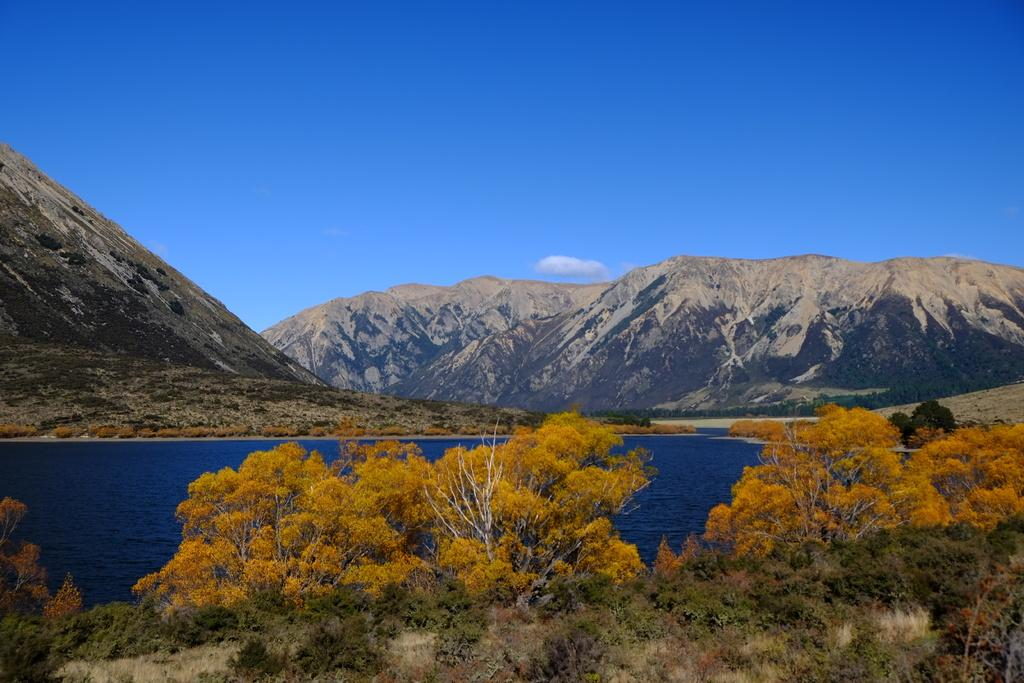What type of vegetation can be seen in the image? There are trees and plants visible in the image. What natural feature is present in the image? There are mountains in the image. What can be seen in the water in the image? The facts do not specify what can be seen in the water. What is visible in the background of the image? The sky is visible in the background of the image, and clouds are present in the sky. What type of roof can be seen on the trees in the image? There is no roof present on the trees in the image; trees do not have roofs. Can you describe the fight between the scissors and the clouds in the image? There is no fight between scissors and clouds in the image, as neither scissors nor a fight are mentioned in the facts. 